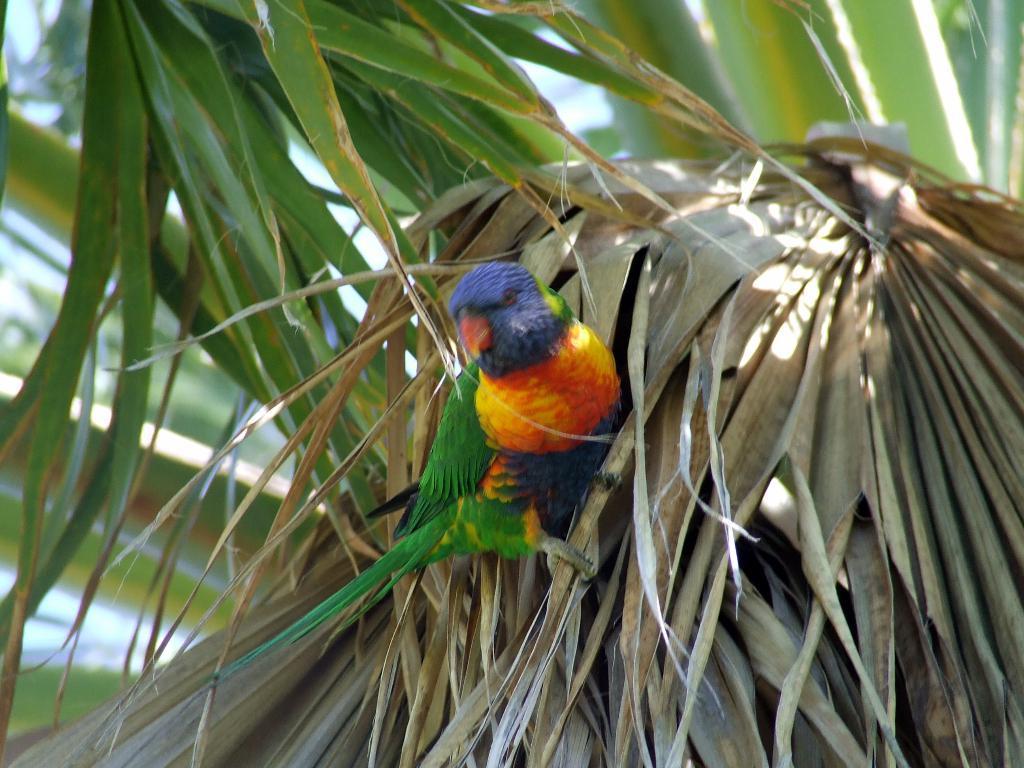Describe this image in one or two sentences. In this image I see a bird which is of green, yellow, orange and blue in color and it is on the dried leaves. In the background I see the green leaves. 